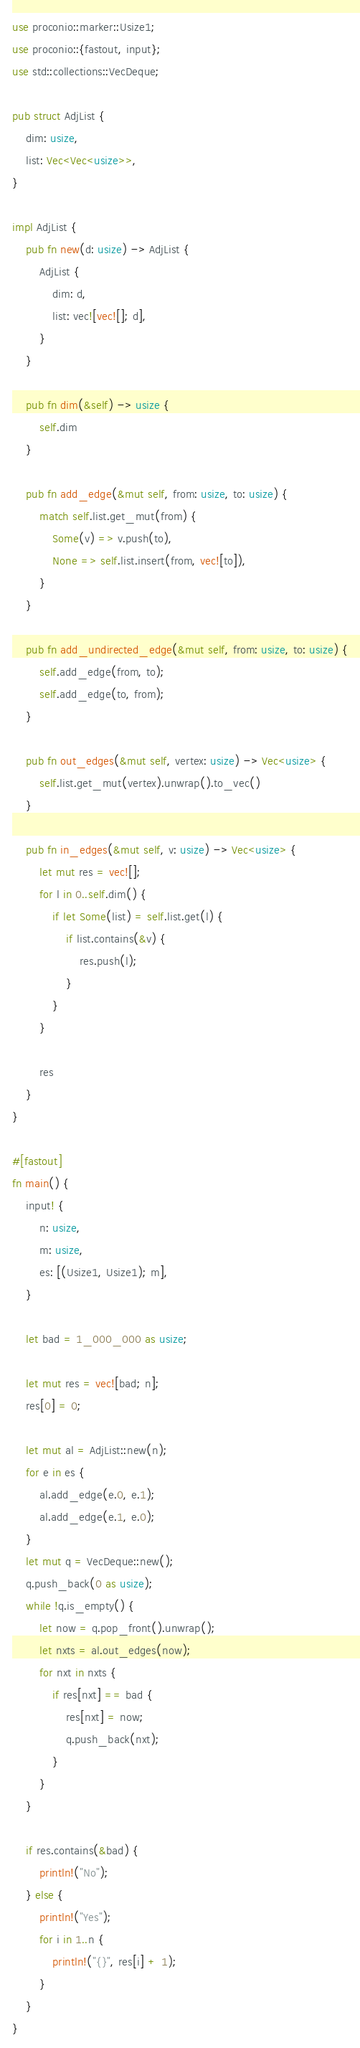<code> <loc_0><loc_0><loc_500><loc_500><_Rust_>use proconio::marker::Usize1;
use proconio::{fastout, input};
use std::collections::VecDeque;

pub struct AdjList {
    dim: usize,
    list: Vec<Vec<usize>>,
}

impl AdjList {
    pub fn new(d: usize) -> AdjList {
        AdjList {
            dim: d,
            list: vec![vec![]; d],
        }
    }

    pub fn dim(&self) -> usize {
        self.dim
    }

    pub fn add_edge(&mut self, from: usize, to: usize) {
        match self.list.get_mut(from) {
            Some(v) => v.push(to),
            None => self.list.insert(from, vec![to]),
        }
    }

    pub fn add_undirected_edge(&mut self, from: usize, to: usize) {
        self.add_edge(from, to);
        self.add_edge(to, from);
    }

    pub fn out_edges(&mut self, vertex: usize) -> Vec<usize> {
        self.list.get_mut(vertex).unwrap().to_vec()
    }

    pub fn in_edges(&mut self, v: usize) -> Vec<usize> {
        let mut res = vec![];
        for l in 0..self.dim() {
            if let Some(list) = self.list.get(l) {
                if list.contains(&v) {
                    res.push(l);
                }
            }
        }

        res
    }
}

#[fastout]
fn main() {
    input! {
        n: usize,
        m: usize,
        es: [(Usize1, Usize1); m],
    }

    let bad = 1_000_000 as usize;

    let mut res = vec![bad; n];
    res[0] = 0;

    let mut al = AdjList::new(n);
    for e in es {
        al.add_edge(e.0, e.1);
        al.add_edge(e.1, e.0);
    }
    let mut q = VecDeque::new();
    q.push_back(0 as usize);
    while !q.is_empty() {
        let now = q.pop_front().unwrap();
        let nxts = al.out_edges(now);
        for nxt in nxts {
            if res[nxt] == bad {
                res[nxt] = now;
                q.push_back(nxt);
            }
        }
    }

    if res.contains(&bad) {
        println!("No");
    } else {
        println!("Yes");
        for i in 1..n {
            println!("{}", res[i] + 1);
        }
    }
}
</code> 